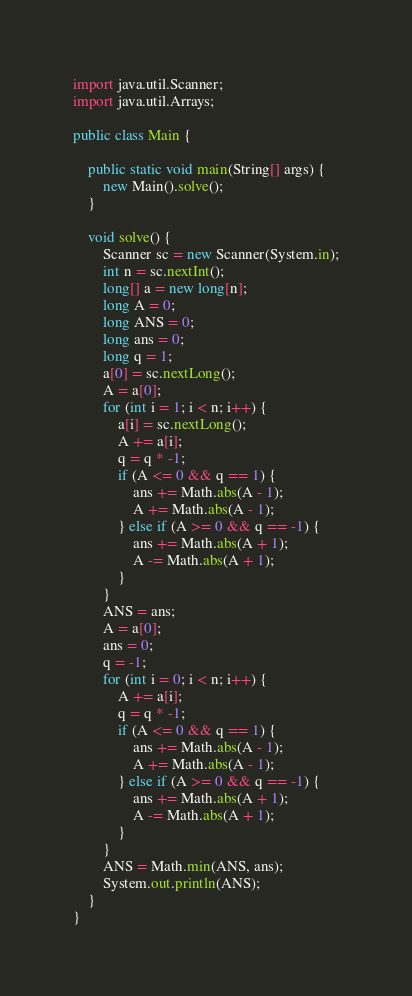Convert code to text. <code><loc_0><loc_0><loc_500><loc_500><_Java_>import java.util.Scanner;
import java.util.Arrays;

public class Main {

    public static void main(String[] args) {
        new Main().solve();
    }

    void solve() {
        Scanner sc = new Scanner(System.in);
        int n = sc.nextInt();
        long[] a = new long[n];
        long A = 0;
        long ANS = 0;
        long ans = 0;
        long q = 1;
        a[0] = sc.nextLong();
        A = a[0];
        for (int i = 1; i < n; i++) {
            a[i] = sc.nextLong();
            A += a[i];
            q = q * -1;
            if (A <= 0 && q == 1) {
                ans += Math.abs(A - 1);
                A += Math.abs(A - 1);
            } else if (A >= 0 && q == -1) {
                ans += Math.abs(A + 1);
                A -= Math.abs(A + 1);
            }
        }
        ANS = ans;
        A = a[0];
        ans = 0;
        q = -1;
        for (int i = 0; i < n; i++) {
            A += a[i];
            q = q * -1;
            if (A <= 0 && q == 1) {
                ans += Math.abs(A - 1);
                A += Math.abs(A - 1);
            } else if (A >= 0 && q == -1) {
                ans += Math.abs(A + 1);
                A -= Math.abs(A + 1);
            }
        }
        ANS = Math.min(ANS, ans);
        System.out.println(ANS);
    }
}</code> 